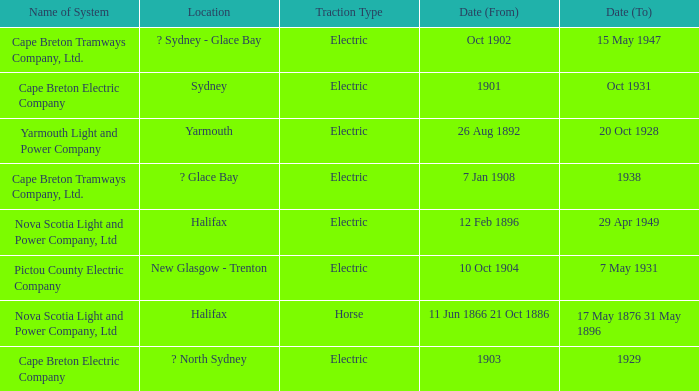What is the date (to) associated wiht a traction type of electric and the Yarmouth Light and Power Company system? 20 Oct 1928. 